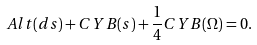<formula> <loc_0><loc_0><loc_500><loc_500>A l t ( d s ) + C Y B ( s ) + \frac { 1 } { 4 } C Y B ( \Omega ) = 0 .</formula> 